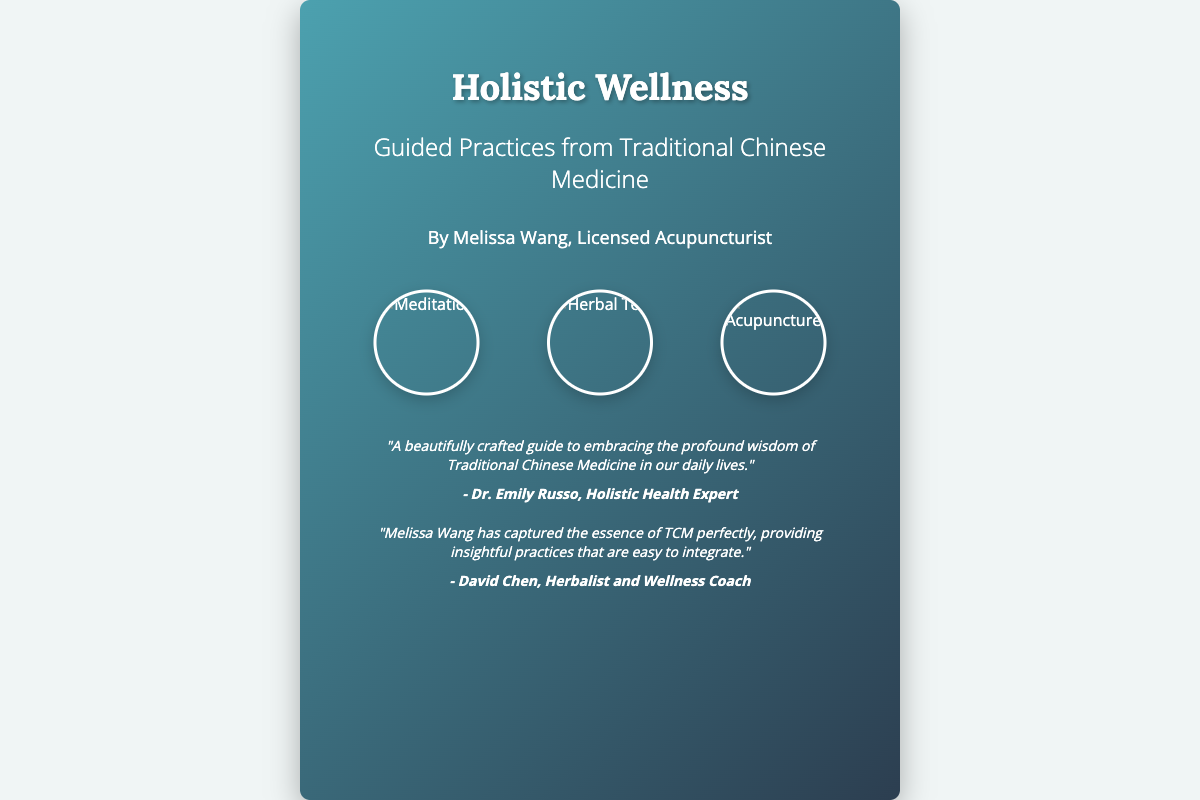What is the title of the book? The title of the book is prominently displayed at the top of the cover.
Answer: Holistic Wellness Who is the author of the book? The author's name is listed beneath the title.
Answer: Melissa Wang, Licensed Acupuncturist What are some of the practices highlighted on the cover? The cover includes visual representations of specific practices related to wellness.
Answer: Meditation, Herbal Tea, Acupuncture What colors are primarily used in the book cover? The cover utilizes soothing tones that create a calming effect.
Answer: Green and blue How many endorsements are featured on the cover? The cover includes a section for endorsements, detailing support from experts.
Answer: Two Who is the first endorser? The first endorsement includes the name of a specific health expert.
Answer: Dr. Emily Russo What type of guide is the book described as? The book is described in the endorsement as a specific type of resource.
Answer: A beautifully crafted guide What is the main theme of the book? The title and subtitle suggest a central focus regarding wellness.
Answer: Guided Practices from Traditional Chinese Medicine 